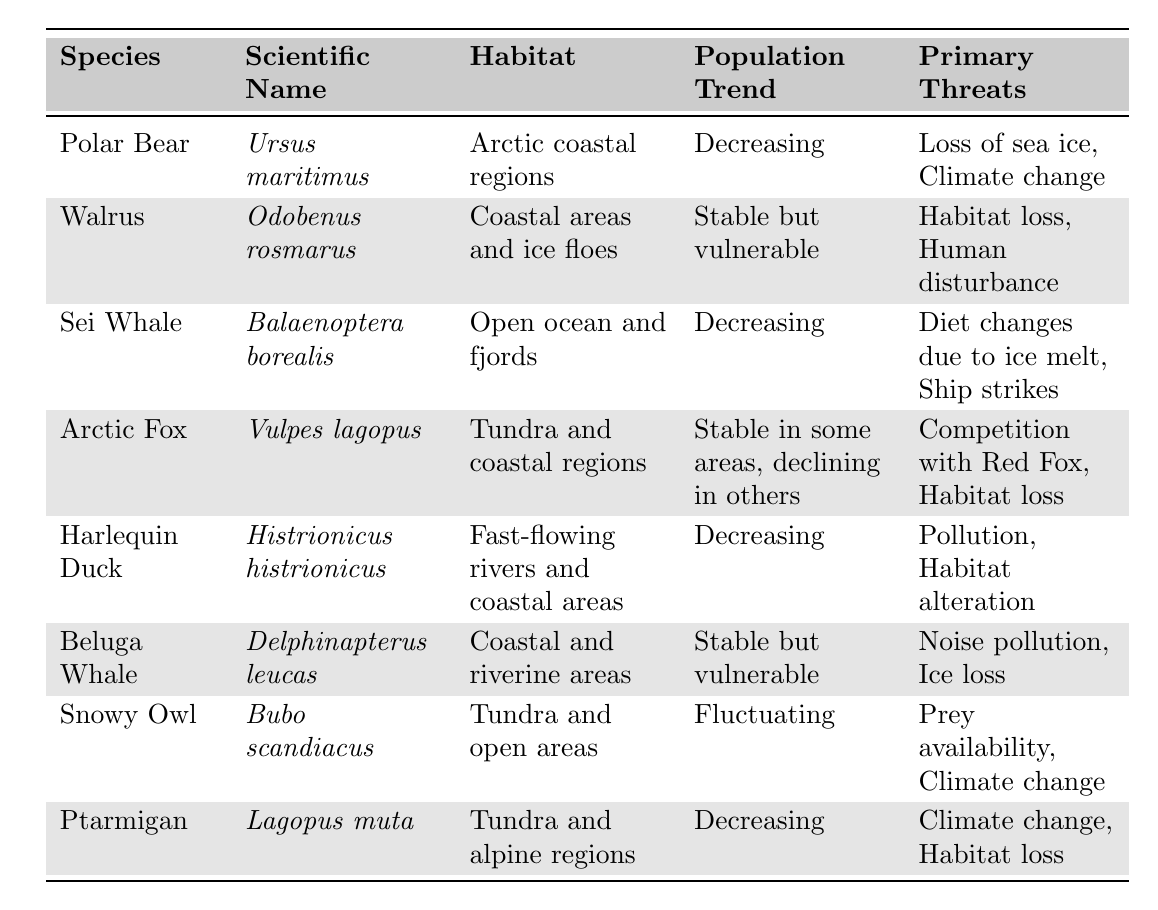What species listed has a decreasing population trend? The table lists multiple species; to find those with a decreasing population trend, I look for "Decreasing" in the Population Trend column. The species that match are Polar Bear, Sei Whale, Harlequin Duck, and Ptarmigan.
Answer: Polar Bear, Sei Whale, Harlequin Duck, Ptarmigan How many species are listed as stable but vulnerable? I check the table for species that are described as "Stable but vulnerable" in the Population Trend column. There are two species: Walrus and Beluga Whale.
Answer: 2 Is the Arctic Fox's population trend stable in all areas? The description in the Population Trend column for Arctic Fox indicates it is "Stable in some areas, declining in others," which suggests it is not stable everywhere.
Answer: No Which primary threat is common to both Polar Bear and Ptarmigan? I look at the Primary Threats column for both species. Polar Bear faces "Loss of sea ice" and "Climate change," while Ptarmigan faces "Climate change" and "Habitat loss." The common threat is "Climate change."
Answer: Climate change Among the species listed, which has the widest diversity of primary threats? I analyze the primary threats for each species: Polar Bear (2), Walrus (2), Sei Whale (2), Arctic Fox (2), Harlequin Duck (2), Beluga Whale (2), Snowy Owl (2), and Ptarmigan (2). All species have 2 threats, so no species exhibits a wider diversity.
Answer: None What is the scientific name of the Harlequin Duck? I directly refer to the table to find the scientific name listed next to Harlequin Duck. It is shown as "Histrionicus histrionicus."
Answer: Histrionicus histrionicus Which species has the most significant concern regarding diet changes due to ice melt? I see that Diet changes due to ice melt are specified as a primary threat for the Sei Whale. Thus, it indicates that this species concerns basing its diet on ice presence.
Answer: Sei Whale What percentage of the species listed have a decreasing population trend? There are 8 species in total, with 4 having a decreasing population trend. To find the percentage, I calculate (4/8) * 100, which equals 50%.
Answer: 50% Does any of the listed species face threats from human disturbance? Inspecting the Primary Threats column reveals that the Walrus faces "Human disturbance" explicitly.
Answer: Yes What difference can be observed in the population trends among the species listed? By examining the Population Trend column, I can see trends of Decreasing, Stable but vulnerable, Stable in some areas declining in others, and Fluctuating. The clear difference is the mixture of trends, with some species declining while others are stable.
Answer: Mixed population trends Which species predominantly lives in coastal areas? I scan the Habitat column for species associated with coastal regions. Polar Bear, Walrus, and Beluga Whale all fit this category.
Answer: Polar Bear, Walrus, Beluga Whale 